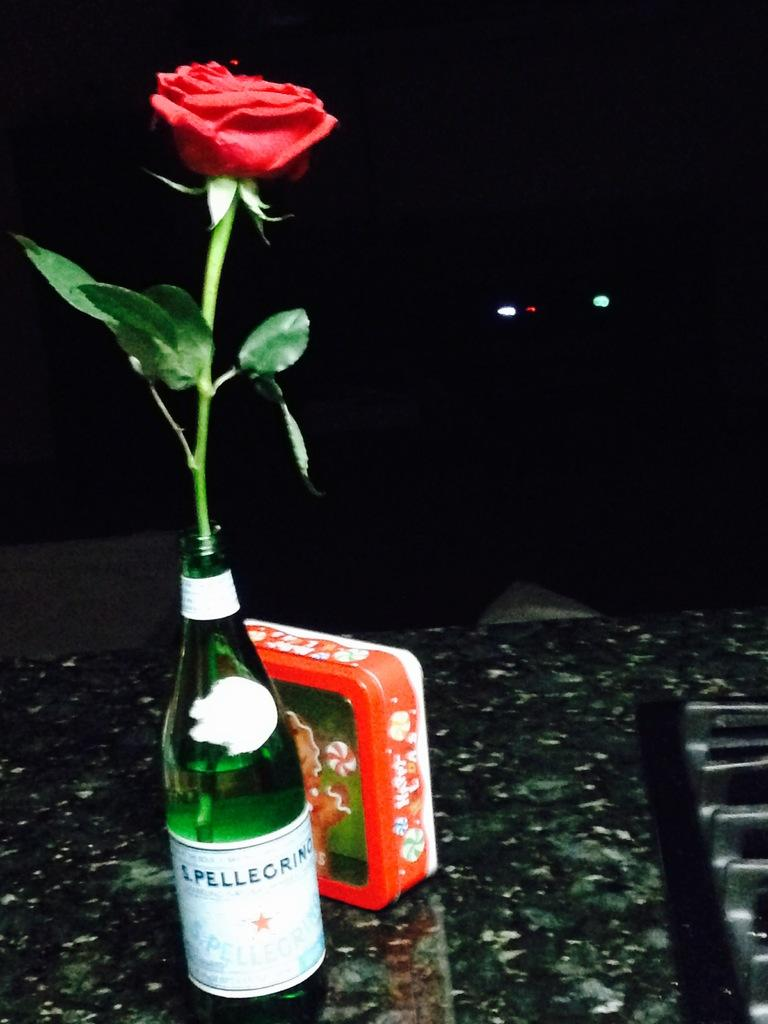What is one object that can be seen in the image? There is a bottle in the image. What is another object that can be seen in the image? There is a box in the image. What is inside the bottle in the image? There is a rose flower in the bottle. How many bananas are on the patch in the image? There are no bananas or patches present in the image. 